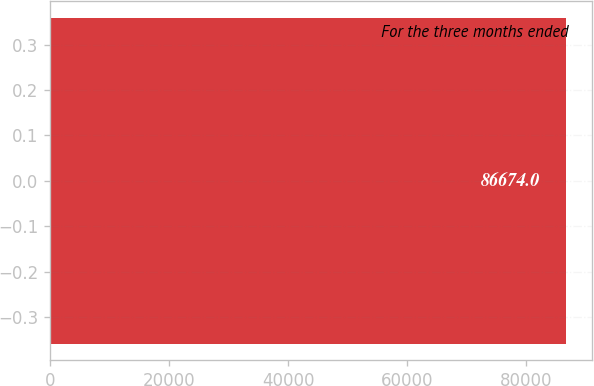<chart> <loc_0><loc_0><loc_500><loc_500><bar_chart><fcel>For the three months ended<nl><fcel>86674<nl></chart> 